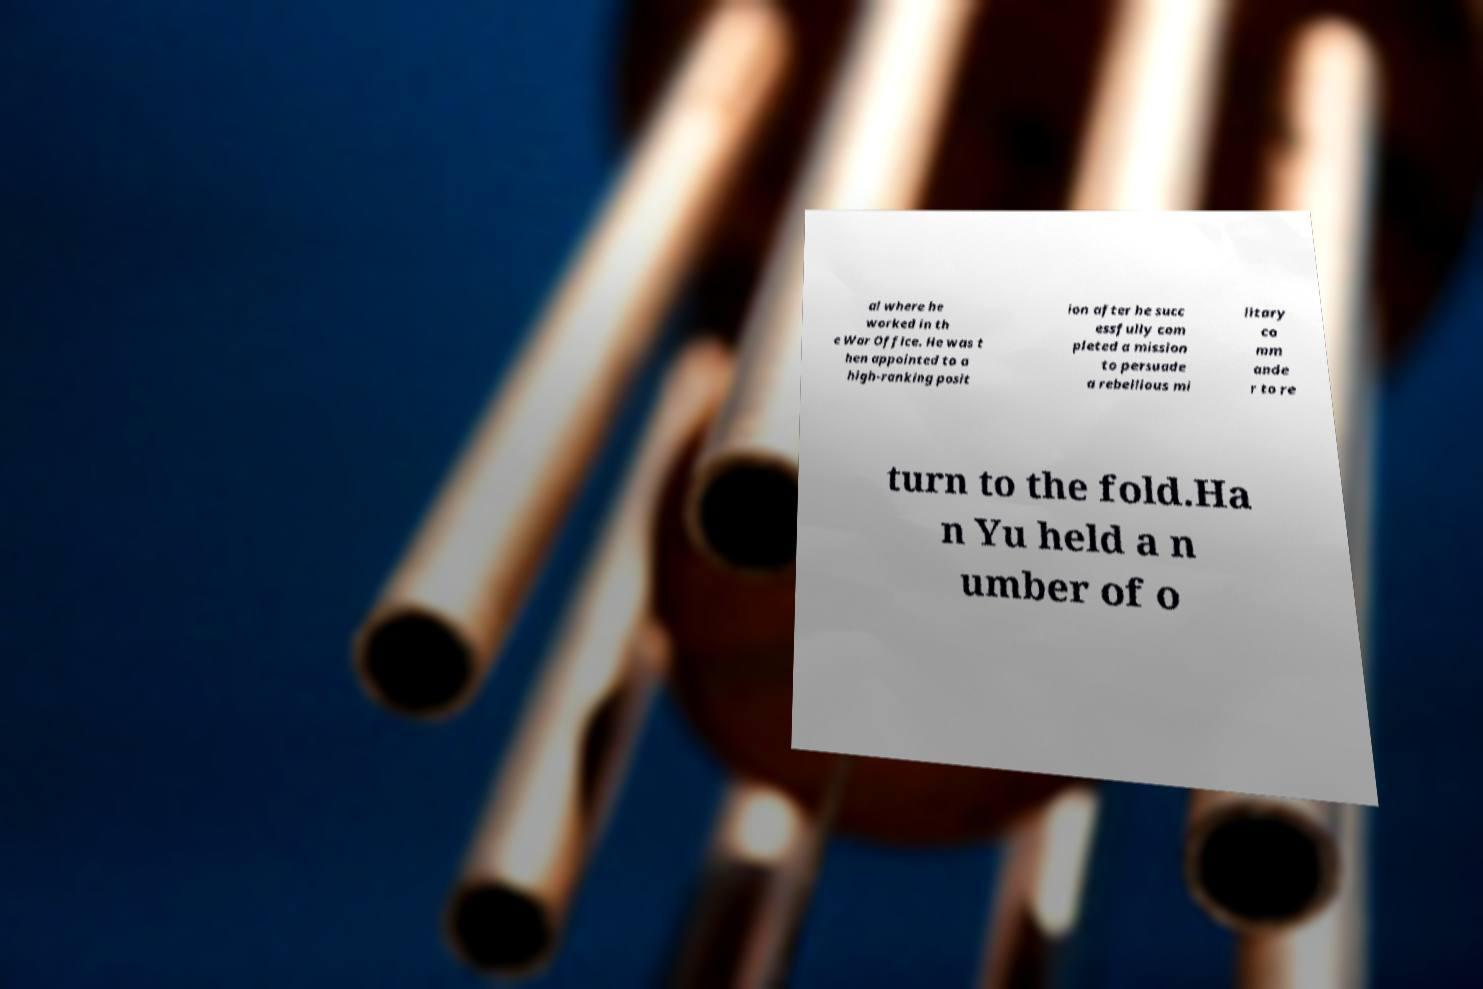Please identify and transcribe the text found in this image. al where he worked in th e War Office. He was t hen appointed to a high-ranking posit ion after he succ essfully com pleted a mission to persuade a rebellious mi litary co mm ande r to re turn to the fold.Ha n Yu held a n umber of o 